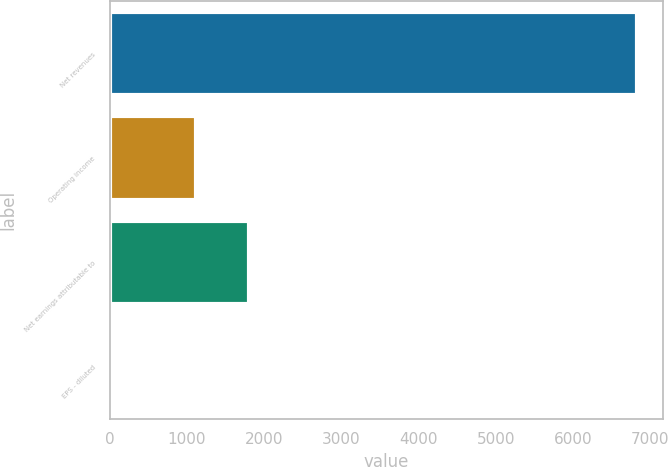Convert chart. <chart><loc_0><loc_0><loc_500><loc_500><bar_chart><fcel>Net revenues<fcel>Operating income<fcel>Net earnings attributable to<fcel>EPS - diluted<nl><fcel>6823<fcel>1121.3<fcel>1803.49<fcel>1.12<nl></chart> 